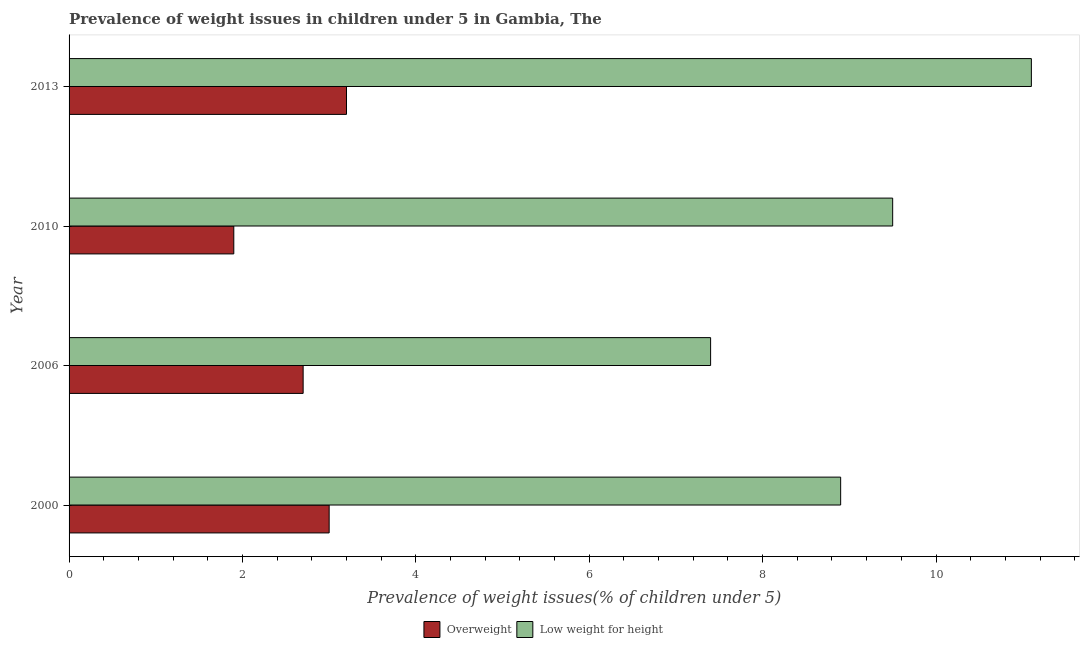How many groups of bars are there?
Provide a succinct answer. 4. How many bars are there on the 4th tick from the top?
Make the answer very short. 2. How many bars are there on the 1st tick from the bottom?
Make the answer very short. 2. What is the label of the 2nd group of bars from the top?
Offer a terse response. 2010. In how many cases, is the number of bars for a given year not equal to the number of legend labels?
Keep it short and to the point. 0. What is the percentage of overweight children in 2013?
Your answer should be very brief. 3.2. Across all years, what is the maximum percentage of underweight children?
Offer a very short reply. 11.1. Across all years, what is the minimum percentage of overweight children?
Make the answer very short. 1.9. In which year was the percentage of underweight children minimum?
Your answer should be compact. 2006. What is the total percentage of overweight children in the graph?
Keep it short and to the point. 10.8. What is the difference between the percentage of overweight children in 2010 and that in 2013?
Provide a short and direct response. -1.3. What is the difference between the percentage of overweight children in 2010 and the percentage of underweight children in 2013?
Keep it short and to the point. -9.2. What is the average percentage of overweight children per year?
Make the answer very short. 2.7. In how many years, is the percentage of overweight children greater than 4.4 %?
Give a very brief answer. 0. What is the ratio of the percentage of underweight children in 2000 to that in 2006?
Keep it short and to the point. 1.2. Is the percentage of overweight children in 2000 less than that in 2010?
Offer a terse response. No. Is the difference between the percentage of overweight children in 2010 and 2013 greater than the difference between the percentage of underweight children in 2010 and 2013?
Ensure brevity in your answer.  Yes. What does the 1st bar from the top in 2013 represents?
Give a very brief answer. Low weight for height. What does the 1st bar from the bottom in 2006 represents?
Ensure brevity in your answer.  Overweight. Are all the bars in the graph horizontal?
Provide a succinct answer. Yes. What is the difference between two consecutive major ticks on the X-axis?
Give a very brief answer. 2. Does the graph contain grids?
Your response must be concise. No. Where does the legend appear in the graph?
Provide a succinct answer. Bottom center. What is the title of the graph?
Your answer should be compact. Prevalence of weight issues in children under 5 in Gambia, The. Does "International Tourists" appear as one of the legend labels in the graph?
Provide a succinct answer. No. What is the label or title of the X-axis?
Keep it short and to the point. Prevalence of weight issues(% of children under 5). What is the label or title of the Y-axis?
Offer a terse response. Year. What is the Prevalence of weight issues(% of children under 5) of Overweight in 2000?
Offer a terse response. 3. What is the Prevalence of weight issues(% of children under 5) in Low weight for height in 2000?
Ensure brevity in your answer.  8.9. What is the Prevalence of weight issues(% of children under 5) in Overweight in 2006?
Give a very brief answer. 2.7. What is the Prevalence of weight issues(% of children under 5) of Low weight for height in 2006?
Your answer should be compact. 7.4. What is the Prevalence of weight issues(% of children under 5) of Overweight in 2010?
Provide a short and direct response. 1.9. What is the Prevalence of weight issues(% of children under 5) in Overweight in 2013?
Provide a succinct answer. 3.2. What is the Prevalence of weight issues(% of children under 5) in Low weight for height in 2013?
Ensure brevity in your answer.  11.1. Across all years, what is the maximum Prevalence of weight issues(% of children under 5) of Overweight?
Your answer should be very brief. 3.2. Across all years, what is the maximum Prevalence of weight issues(% of children under 5) in Low weight for height?
Ensure brevity in your answer.  11.1. Across all years, what is the minimum Prevalence of weight issues(% of children under 5) of Overweight?
Offer a very short reply. 1.9. Across all years, what is the minimum Prevalence of weight issues(% of children under 5) in Low weight for height?
Make the answer very short. 7.4. What is the total Prevalence of weight issues(% of children under 5) of Overweight in the graph?
Give a very brief answer. 10.8. What is the total Prevalence of weight issues(% of children under 5) in Low weight for height in the graph?
Make the answer very short. 36.9. What is the difference between the Prevalence of weight issues(% of children under 5) of Low weight for height in 2000 and that in 2006?
Make the answer very short. 1.5. What is the difference between the Prevalence of weight issues(% of children under 5) in Low weight for height in 2000 and that in 2013?
Make the answer very short. -2.2. What is the difference between the Prevalence of weight issues(% of children under 5) in Overweight in 2006 and that in 2013?
Your response must be concise. -0.5. What is the difference between the Prevalence of weight issues(% of children under 5) in Low weight for height in 2006 and that in 2013?
Offer a very short reply. -3.7. What is the difference between the Prevalence of weight issues(% of children under 5) in Overweight in 2010 and that in 2013?
Provide a succinct answer. -1.3. What is the difference between the Prevalence of weight issues(% of children under 5) of Overweight in 2000 and the Prevalence of weight issues(% of children under 5) of Low weight for height in 2010?
Keep it short and to the point. -6.5. What is the difference between the Prevalence of weight issues(% of children under 5) of Overweight in 2006 and the Prevalence of weight issues(% of children under 5) of Low weight for height in 2010?
Your response must be concise. -6.8. What is the average Prevalence of weight issues(% of children under 5) of Overweight per year?
Provide a short and direct response. 2.7. What is the average Prevalence of weight issues(% of children under 5) of Low weight for height per year?
Give a very brief answer. 9.22. In the year 2013, what is the difference between the Prevalence of weight issues(% of children under 5) in Overweight and Prevalence of weight issues(% of children under 5) in Low weight for height?
Your response must be concise. -7.9. What is the ratio of the Prevalence of weight issues(% of children under 5) of Overweight in 2000 to that in 2006?
Your response must be concise. 1.11. What is the ratio of the Prevalence of weight issues(% of children under 5) in Low weight for height in 2000 to that in 2006?
Offer a terse response. 1.2. What is the ratio of the Prevalence of weight issues(% of children under 5) in Overweight in 2000 to that in 2010?
Provide a short and direct response. 1.58. What is the ratio of the Prevalence of weight issues(% of children under 5) of Low weight for height in 2000 to that in 2010?
Ensure brevity in your answer.  0.94. What is the ratio of the Prevalence of weight issues(% of children under 5) in Low weight for height in 2000 to that in 2013?
Keep it short and to the point. 0.8. What is the ratio of the Prevalence of weight issues(% of children under 5) in Overweight in 2006 to that in 2010?
Keep it short and to the point. 1.42. What is the ratio of the Prevalence of weight issues(% of children under 5) of Low weight for height in 2006 to that in 2010?
Provide a succinct answer. 0.78. What is the ratio of the Prevalence of weight issues(% of children under 5) of Overweight in 2006 to that in 2013?
Offer a terse response. 0.84. What is the ratio of the Prevalence of weight issues(% of children under 5) of Low weight for height in 2006 to that in 2013?
Offer a very short reply. 0.67. What is the ratio of the Prevalence of weight issues(% of children under 5) in Overweight in 2010 to that in 2013?
Provide a succinct answer. 0.59. What is the ratio of the Prevalence of weight issues(% of children under 5) of Low weight for height in 2010 to that in 2013?
Your answer should be very brief. 0.86. What is the difference between the highest and the second highest Prevalence of weight issues(% of children under 5) in Overweight?
Your answer should be very brief. 0.2. What is the difference between the highest and the second highest Prevalence of weight issues(% of children under 5) of Low weight for height?
Keep it short and to the point. 1.6. What is the difference between the highest and the lowest Prevalence of weight issues(% of children under 5) of Overweight?
Provide a short and direct response. 1.3. What is the difference between the highest and the lowest Prevalence of weight issues(% of children under 5) of Low weight for height?
Give a very brief answer. 3.7. 